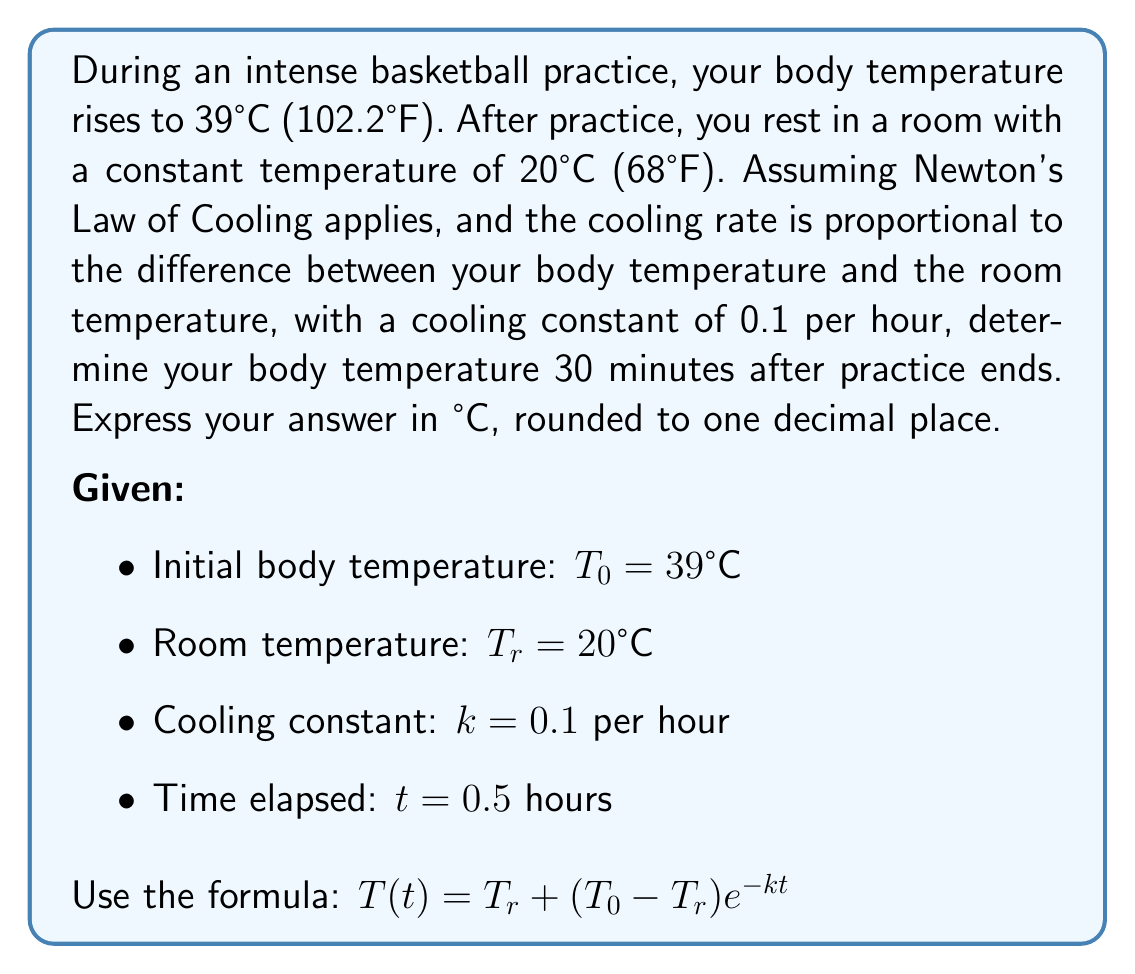Can you solve this math problem? To solve this problem, we'll use Newton's Law of Cooling, which states that the rate of change of the temperature of an object is proportional to the difference between its own temperature and the ambient temperature.

The formula for Newton's Law of Cooling is:

$$T(t) = T_r + (T_0 - T_r)e^{-kt}$$

Where:
$T(t)$ is the temperature at time $t$
$T_r$ is the room temperature
$T_0$ is the initial temperature
$k$ is the cooling constant
$t$ is the time elapsed

Let's substitute the given values into the formula:

$T_r = 20°C$
$T_0 = 39°C$
$k = 0.1$ per hour
$t = 0.5$ hours

$$T(0.5) = 20 + (39 - 20)e^{-0.1 \cdot 0.5}$$

Now, let's solve this step by step:

1) First, calculate the temperature difference:
   $39 - 20 = 19$

2) Then, calculate the exponent:
   $-0.1 \cdot 0.5 = -0.05$

3) Now, our equation looks like this:
   $$T(0.5) = 20 + 19e^{-0.05}$$

4) Calculate $e^{-0.05}$:
   $e^{-0.05} \approx 0.9512$

5) Multiply:
   $19 \cdot 0.9512 \approx 18.0728$

6) Add this to the room temperature:
   $20 + 18.0728 \approx 38.0728°C$

7) Round to one decimal place:
   $38.1°C$
Answer: $38.1°C$ 